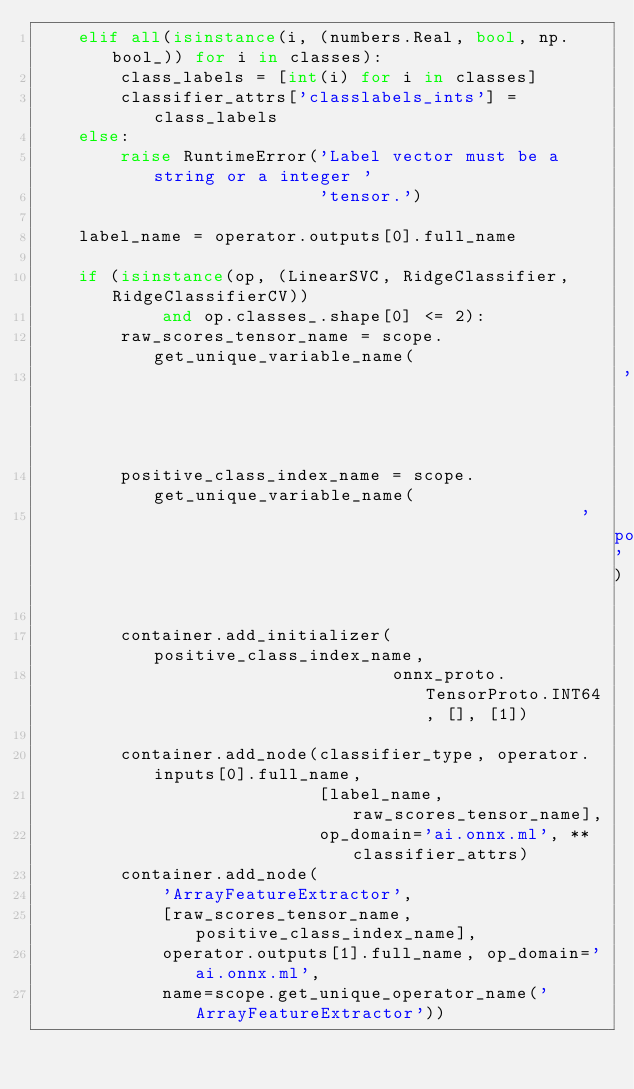Convert code to text. <code><loc_0><loc_0><loc_500><loc_500><_Python_>    elif all(isinstance(i, (numbers.Real, bool, np.bool_)) for i in classes):
        class_labels = [int(i) for i in classes]
        classifier_attrs['classlabels_ints'] = class_labels
    else:
        raise RuntimeError('Label vector must be a string or a integer '
                           'tensor.')

    label_name = operator.outputs[0].full_name

    if (isinstance(op, (LinearSVC, RidgeClassifier, RidgeClassifierCV))
            and op.classes_.shape[0] <= 2):
        raw_scores_tensor_name = scope.get_unique_variable_name(
                                                        'raw_scores_tensor')
        positive_class_index_name = scope.get_unique_variable_name(
                                                    'positive_class_index')

        container.add_initializer(positive_class_index_name,
                                  onnx_proto.TensorProto.INT64, [], [1])

        container.add_node(classifier_type, operator.inputs[0].full_name,
                           [label_name, raw_scores_tensor_name],
                           op_domain='ai.onnx.ml', **classifier_attrs)
        container.add_node(
            'ArrayFeatureExtractor',
            [raw_scores_tensor_name, positive_class_index_name],
            operator.outputs[1].full_name, op_domain='ai.onnx.ml',
            name=scope.get_unique_operator_name('ArrayFeatureExtractor'))</code> 